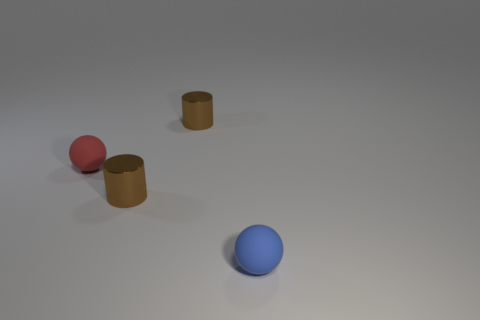Add 2 large green blocks. How many objects exist? 6 Subtract all brown metallic things. Subtract all matte objects. How many objects are left? 0 Add 4 blue balls. How many blue balls are left? 5 Add 1 tiny red matte objects. How many tiny red matte objects exist? 2 Subtract 2 brown cylinders. How many objects are left? 2 